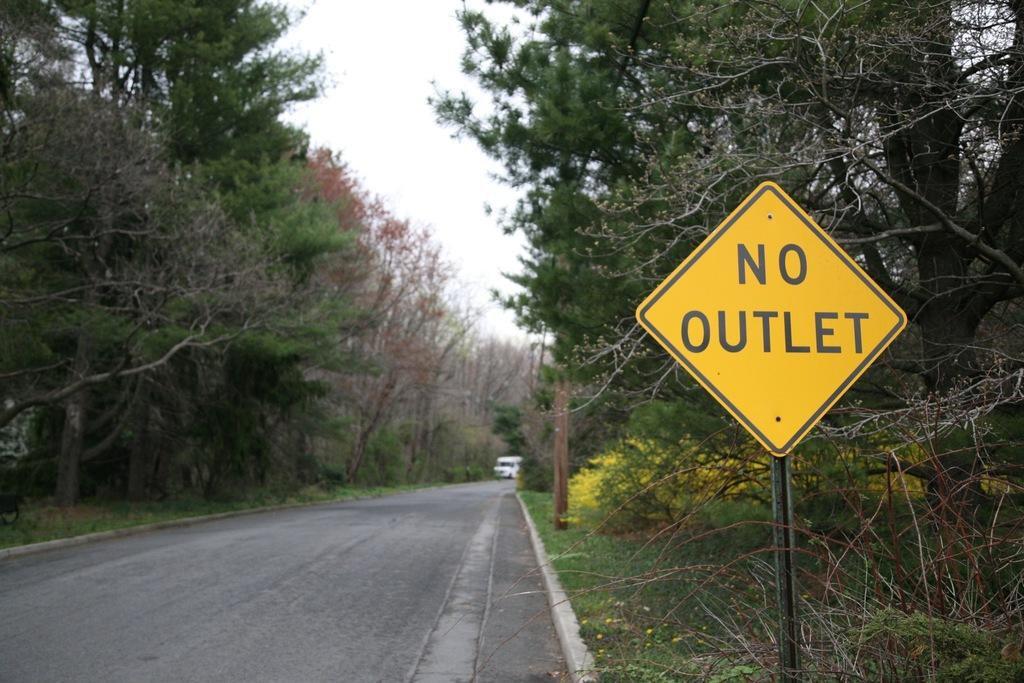<image>
Summarize the visual content of the image. A street is lined with pine trees on both sides; to the right, a sign reads NO OUTLET. 